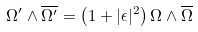Convert formula to latex. <formula><loc_0><loc_0><loc_500><loc_500>\Omega ^ { \prime } \wedge \overline { \Omega ^ { \prime } } = \left ( 1 + | \epsilon | ^ { 2 } \right ) \Omega \wedge \overline { \Omega }</formula> 